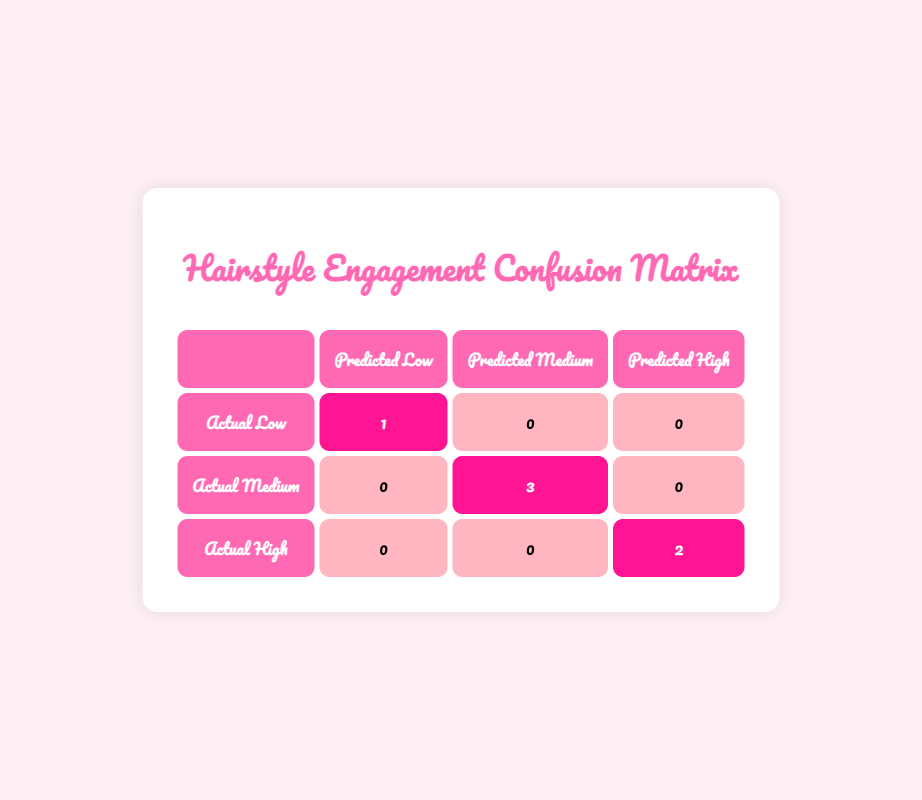What is the predicted engagement level for the Beach Waves hairstyle? The table shows that the predicted engagement level for the Beach Waves hairstyle is "High." This information is found in the first entry of the hairstyles listed.
Answer: High How many hairstyles are categorized as having medium predicted engagement? According to the table, there are three hairstyles that fall under the "Medium" predicted engagement category: Pixie Cut, Sleek Ponytail, and Messy Bun. This is determined by counting the entries labeled as "Medium" in the predicted engagement column.
Answer: 3 Is there any hairstyle predicted to have low engagement that has more than 500 likes? The table indicates that the Bouncy Curls hairstyle is predicted to have "Low" engagement, but it has only 500 likes, which does not exceed the threshold of 500 likes. Thus, there is no hairstyle predicted as low engagement with more than 500 likes.
Answer: No What is the total number of hairstyles predicted with high engagement? The table indicates that there are two hairstyles predicted with high engagement: Beach Waves and Braided Updo. Adding these gives a total of 2 hairstyles.
Answer: 2 Which hairstyle predicted low engagement received the most likes? The Bouncy Curls is the only hairstyle predicted with low engagement, and it received 500 likes. There are no other hairstyles in this category to compare with, confirming that Bouncy Curls is the highest.
Answer: Bouncy Curls How many hairstyles received more than 800 likes, and how many were predicted to have high engagement? The hairstyles that received more than 800 likes are Beach Waves, Pixie Cut, Braided Updo, Messy Bun, totaling four hairstyles. Among these, Braided Updo and Beach Waves are in the high engagement category, which gives a total of 2 hairstyles predicted to have high engagement.
Answer: 4 and 2 What percentage of hairstyles predicted high engagement succeeded in that classification? There are 2 hairstyles predicted to have high engagement (Beach Waves and Braided Updo) and they both actually belong to that category. To calculate the percentage, (2 predicted high/2 actual high) * 100 equals 100%.
Answer: 100% 